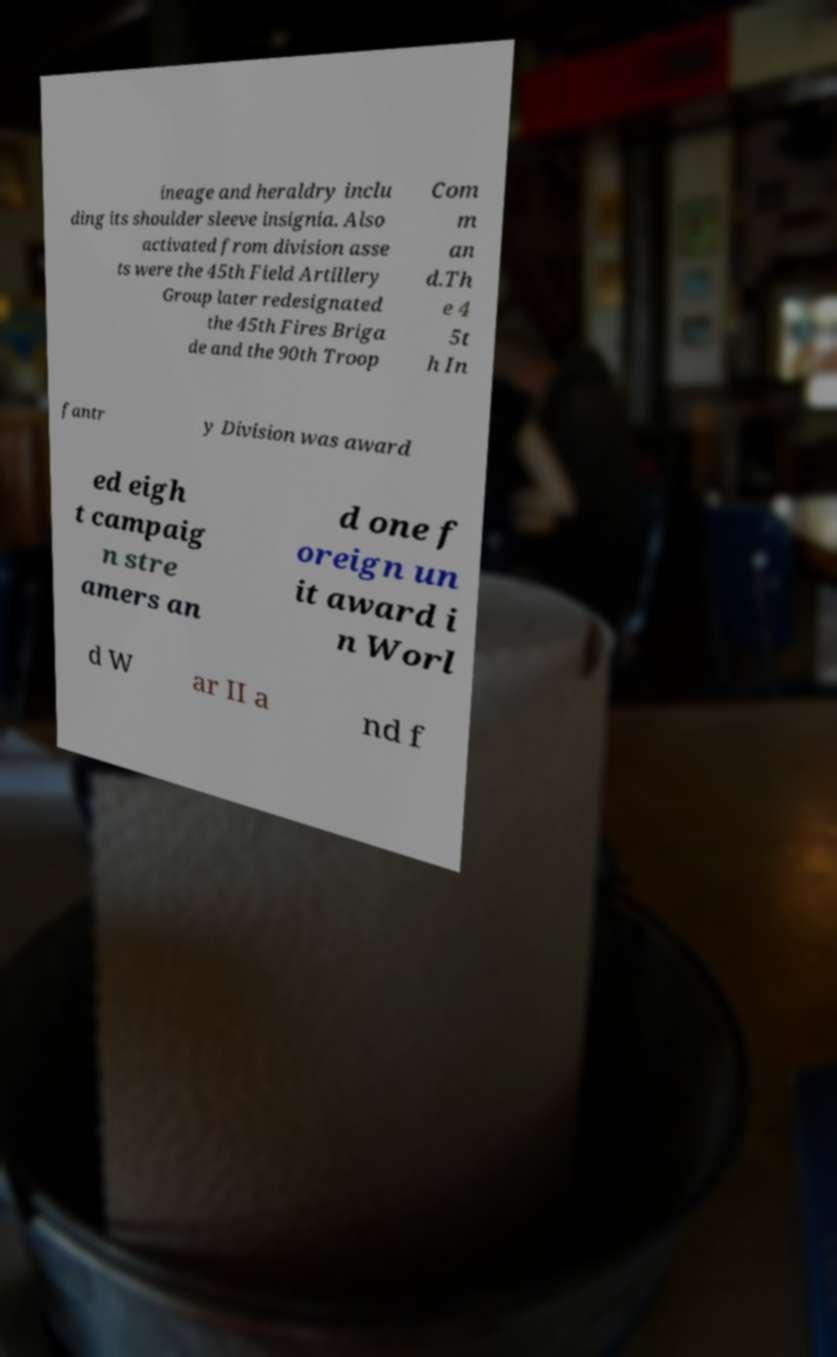Could you extract and type out the text from this image? ineage and heraldry inclu ding its shoulder sleeve insignia. Also activated from division asse ts were the 45th Field Artillery Group later redesignated the 45th Fires Briga de and the 90th Troop Com m an d.Th e 4 5t h In fantr y Division was award ed eigh t campaig n stre amers an d one f oreign un it award i n Worl d W ar II a nd f 